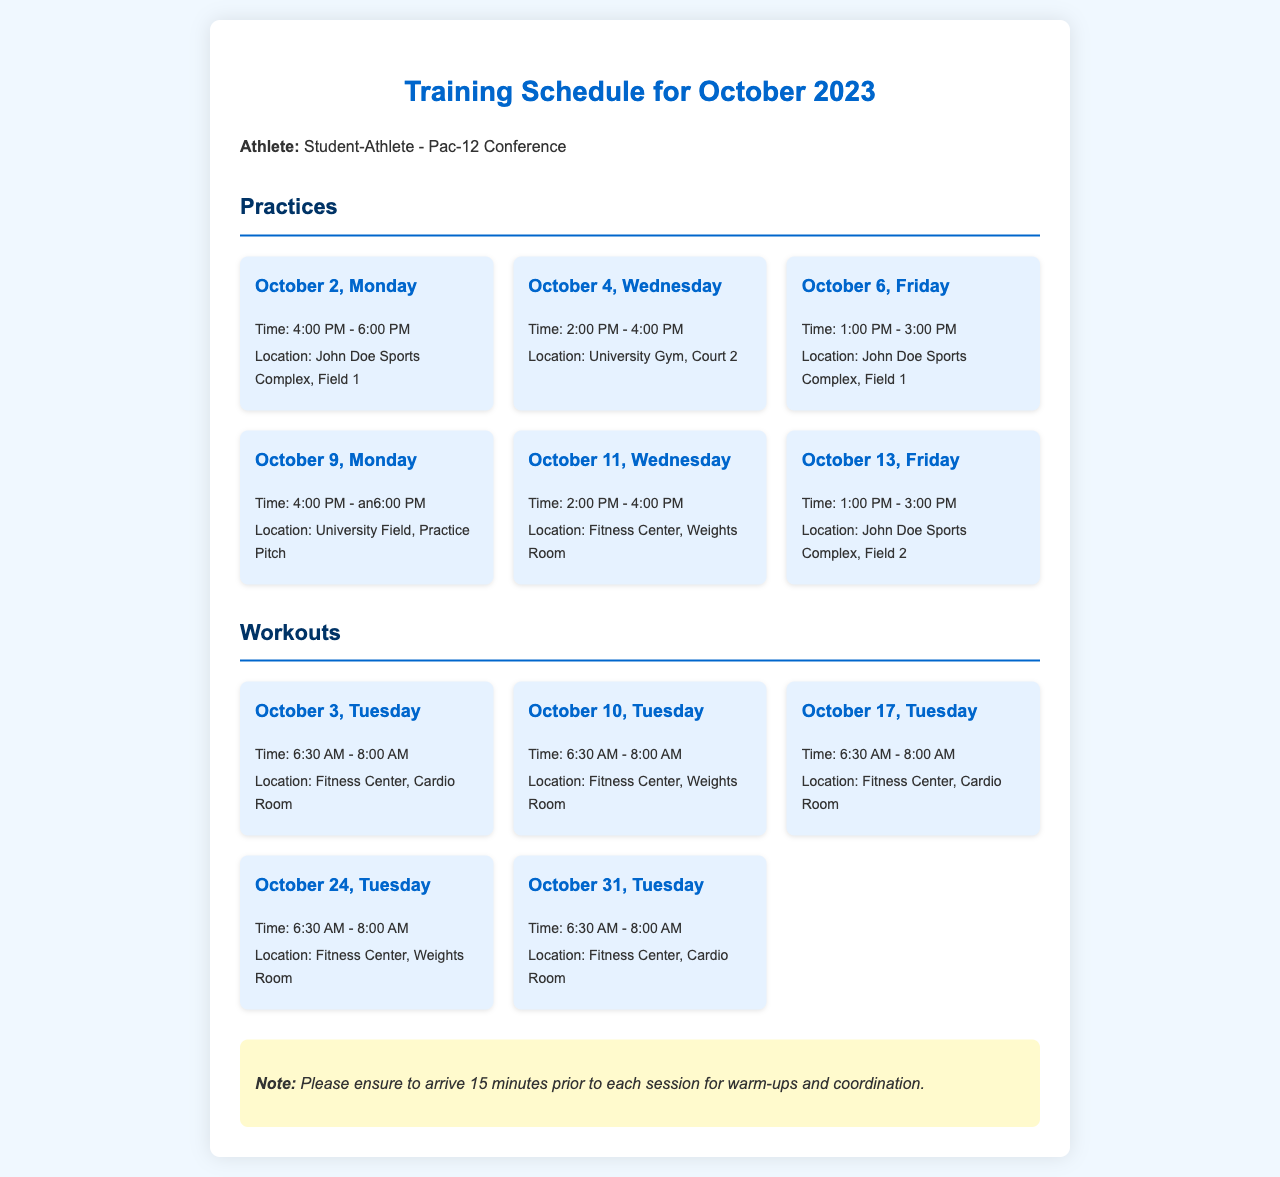what is the first practice date in October? The first practice is on October 2, as specified in the schedule.
Answer: October 2 how long is each workout session? Each workout session is scheduled for 1.5 hours, from 6:30 AM to 8:00 AM.
Answer: 1.5 hours where is the practice on October 9 located? The location for the practice on October 9 is indicated as University Field, Practice Pitch.
Answer: University Field, Practice Pitch what time does the last workout session start? The last workout session on October 31 begins at 6:30 AM.
Answer: 6:30 AM how many practices are scheduled for October? There are a total of 6 practices listed for October in the document.
Answer: 6 which location is used for workouts on October 10? The workout session on October 10 is held in the Fitness Center, Weights Room.
Answer: Fitness Center, Weights Room what color is the background of the document? The document features a light blue background color (#f0f8ff).
Answer: light blue when should athletes arrive before each session? Athletes are advised to arrive 15 minutes prior for warm-ups and coordination.
Answer: 15 minutes 